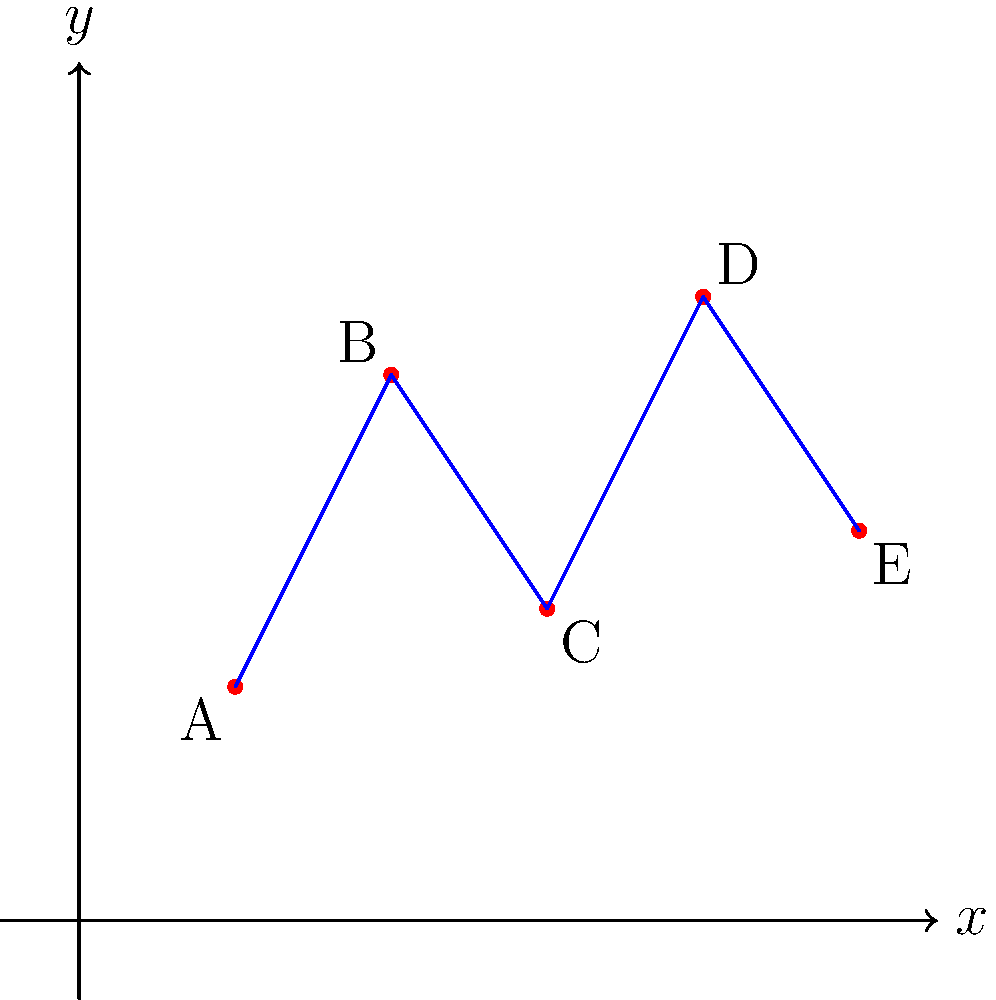As an event planner for a large corporate seminar, you need to determine the most efficient route for catering staff to serve refreshments to attendees. The conference hall can be represented as a coordinate system, where each point represents a serving station. Given the following coordinates for five serving stations: A(2,3), B(4,7), C(6,4), D(8,8), and E(10,5), what is the total distance the catering staff will travel if they visit all stations in alphabetical order? Round your answer to the nearest whole number. To solve this problem, we need to calculate the distance between consecutive points and sum them up. We can use the distance formula between two points: $d = \sqrt{(x_2-x_1)^2 + (y_2-y_1)^2}$

Step 1: Calculate distance from A to B
$d_{AB} = \sqrt{(4-2)^2 + (7-3)^2} = \sqrt{4^2 + 4^2} = \sqrt{32} \approx 5.66$

Step 2: Calculate distance from B to C
$d_{BC} = \sqrt{(6-4)^2 + (4-7)^2} = \sqrt{2^2 + (-3)^2} = \sqrt{13} \approx 3.61$

Step 3: Calculate distance from C to D
$d_{CD} = \sqrt{(8-6)^2 + (8-4)^2} = \sqrt{2^2 + 4^2} = \sqrt{20} \approx 4.47$

Step 4: Calculate distance from D to E
$d_{DE} = \sqrt{(10-8)^2 + (5-8)^2} = \sqrt{2^2 + (-3)^2} = \sqrt{13} \approx 3.61$

Step 5: Sum up all distances
Total distance = $d_{AB} + d_{BC} + d_{CD} + d_{DE}$
$\approx 5.66 + 3.61 + 4.47 + 3.61 = 17.35$

Step 6: Round to the nearest whole number
$17.35 \approx 17$

Therefore, the total distance traveled by the catering staff is approximately 17 units.
Answer: 17 units 